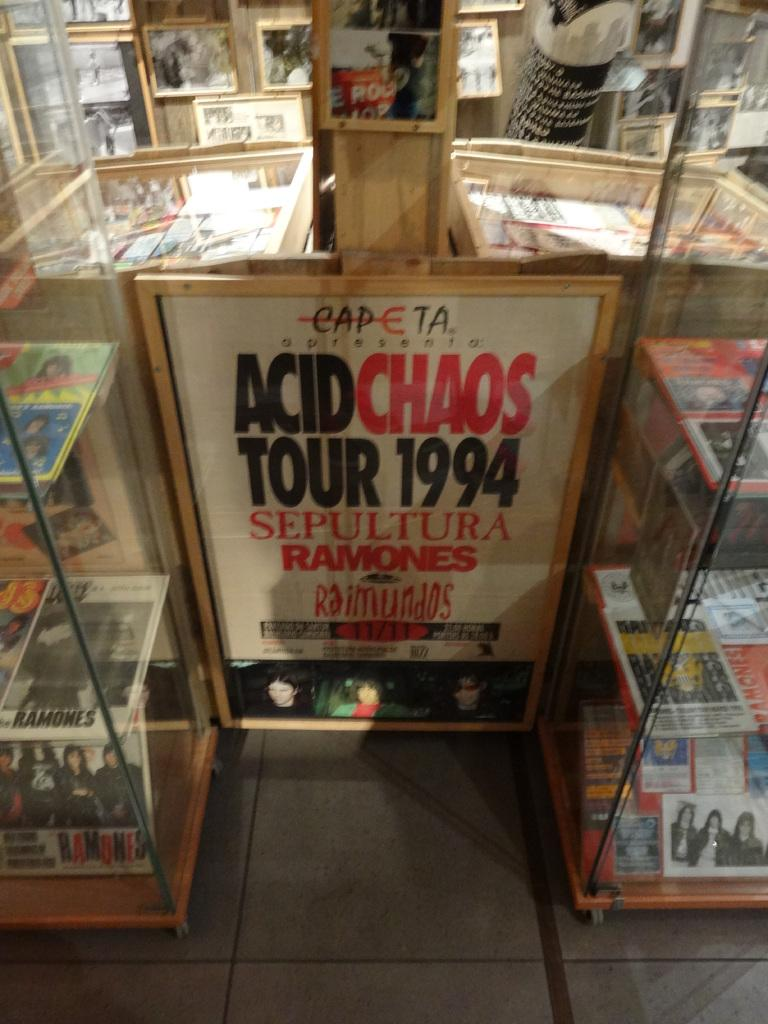<image>
Render a clear and concise summary of the photo. Sign in front of a store which has the year 1994 on it. 